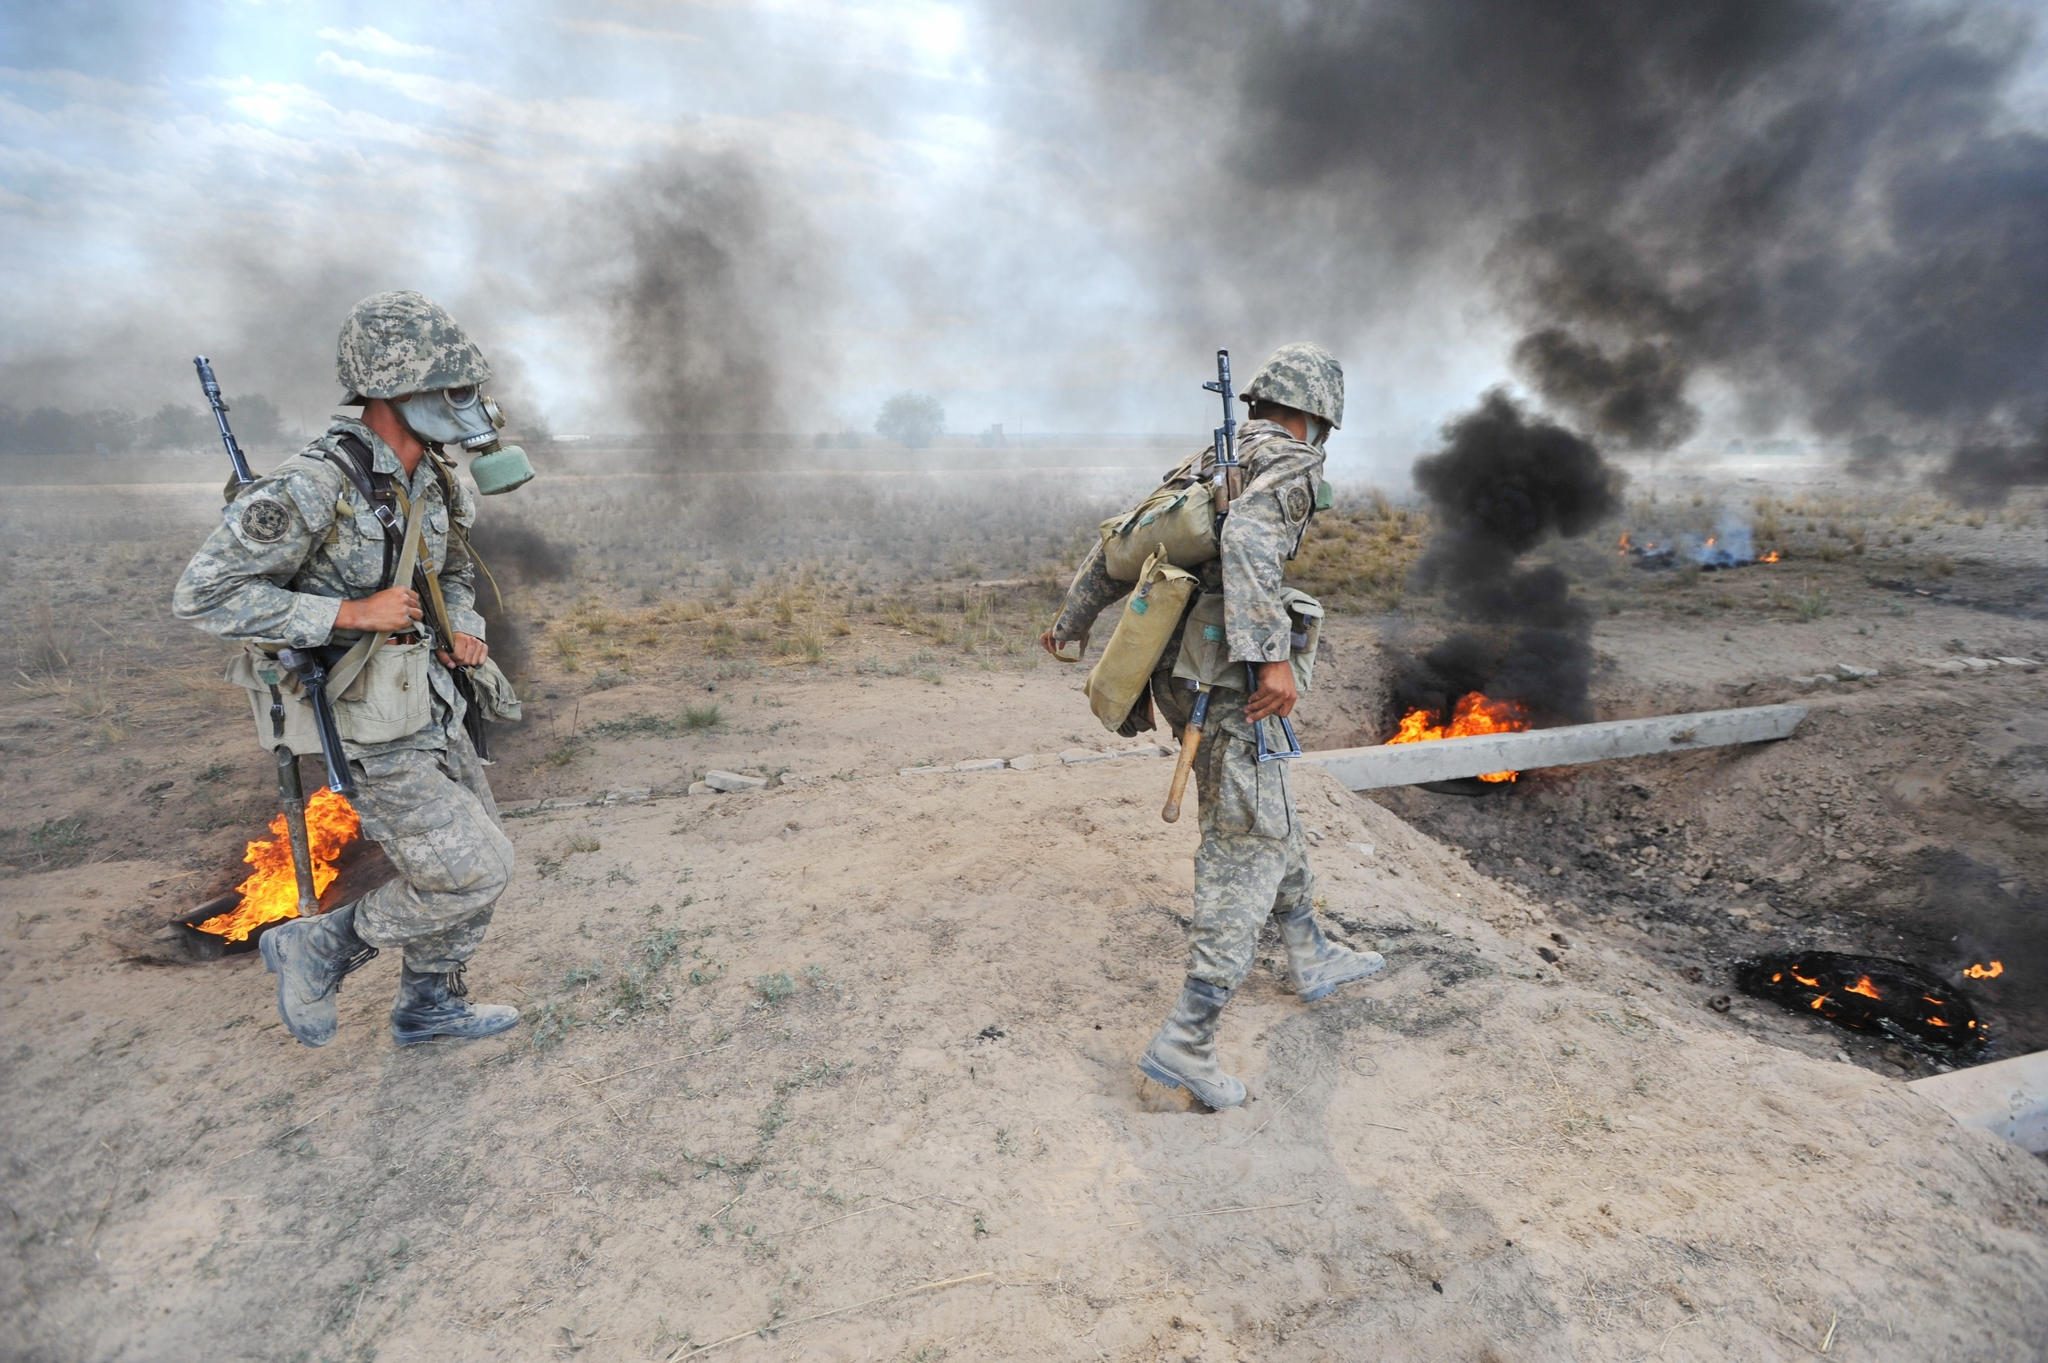What kind of operation do you think is taking place in this image? The image likely depicts a military operation in a combat zone. Given the presence of smoke, flames, and debris, it could be an aftermath of a targeted strike or an explosive detonation. The soldiers are in full gear, suggesting they were actively engaged in or securing the area. They could be performing reconnaissance, rescue operations, or neutralizing threats based on the context provided. How do the soldiers' actions hint at the completion of their mission? The soldiers in the image are seen walking away from the area of intense smoke and flames. This movement can indicate that they may have completed a key operation, such as a tactical assault, neutralizing an explosive threat, or securing a perimeter. The careful but purposeful pace suggests they are moving to a new position or heading back to a safer zone, implying the primary objective in that specific area might have been accomplished. 